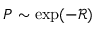Convert formula to latex. <formula><loc_0><loc_0><loc_500><loc_500>P \sim \exp ( - { \mathcal { R } } )</formula> 